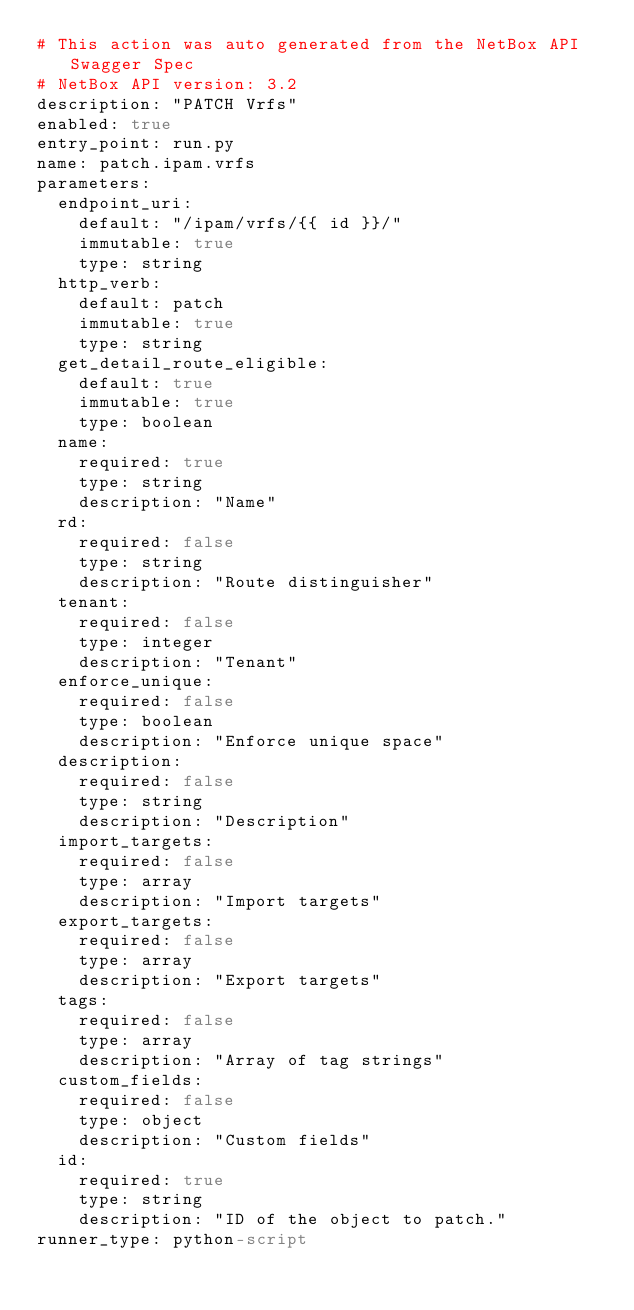Convert code to text. <code><loc_0><loc_0><loc_500><loc_500><_YAML_># This action was auto generated from the NetBox API Swagger Spec
# NetBox API version: 3.2
description: "PATCH Vrfs"
enabled: true
entry_point: run.py
name: patch.ipam.vrfs
parameters:
  endpoint_uri:
    default: "/ipam/vrfs/{{ id }}/"
    immutable: true
    type: string
  http_verb:
    default: patch
    immutable: true
    type: string
  get_detail_route_eligible:
    default: true
    immutable: true
    type: boolean
  name:
    required: true
    type: string
    description: "Name"
  rd:
    required: false
    type: string
    description: "Route distinguisher"
  tenant:
    required: false
    type: integer
    description: "Tenant"
  enforce_unique:
    required: false
    type: boolean
    description: "Enforce unique space"
  description:
    required: false
    type: string
    description: "Description"
  import_targets:
    required: false
    type: array
    description: "Import targets"
  export_targets:
    required: false
    type: array
    description: "Export targets"
  tags:
    required: false
    type: array
    description: "Array of tag strings"
  custom_fields:
    required: false
    type: object
    description: "Custom fields"
  id:
    required: true
    type: string
    description: "ID of the object to patch."
runner_type: python-script</code> 